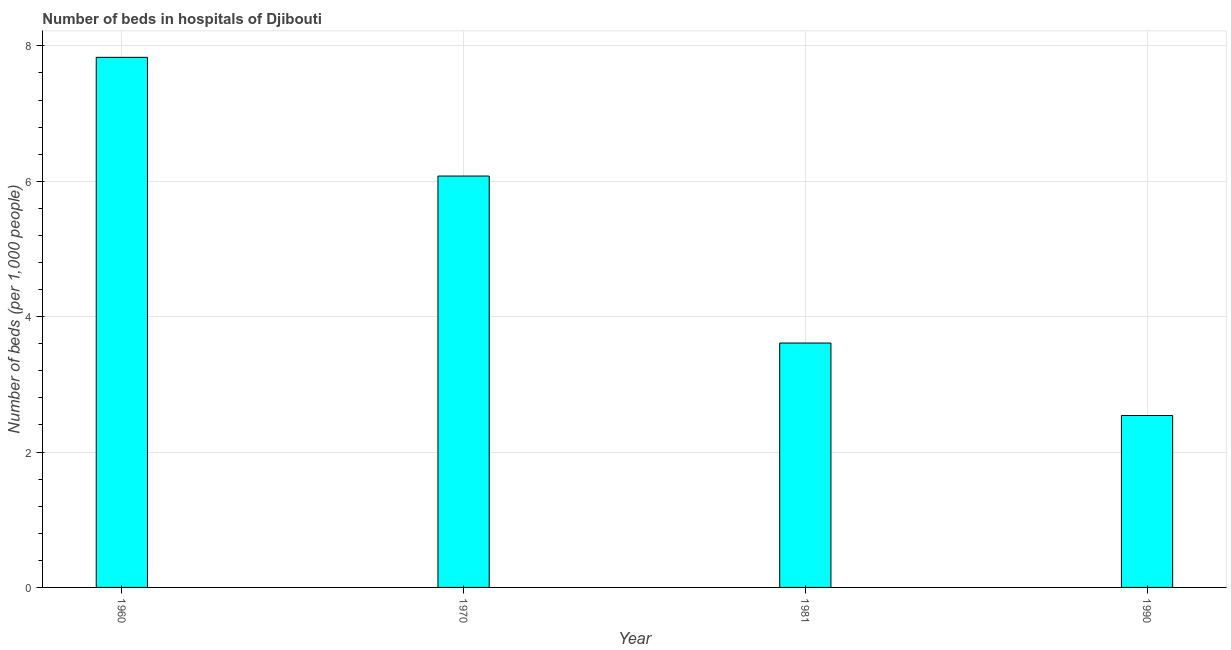Does the graph contain grids?
Make the answer very short. Yes. What is the title of the graph?
Make the answer very short. Number of beds in hospitals of Djibouti. What is the label or title of the Y-axis?
Make the answer very short. Number of beds (per 1,0 people). What is the number of hospital beds in 1960?
Offer a very short reply. 7.83. Across all years, what is the maximum number of hospital beds?
Offer a very short reply. 7.83. Across all years, what is the minimum number of hospital beds?
Ensure brevity in your answer.  2.54. What is the sum of the number of hospital beds?
Provide a short and direct response. 20.06. What is the difference between the number of hospital beds in 1970 and 1990?
Provide a short and direct response. 3.54. What is the average number of hospital beds per year?
Provide a succinct answer. 5.01. What is the median number of hospital beds?
Keep it short and to the point. 4.84. In how many years, is the number of hospital beds greater than 3.6 %?
Your answer should be compact. 3. What is the ratio of the number of hospital beds in 1960 to that in 1990?
Keep it short and to the point. 3.08. Is the number of hospital beds in 1960 less than that in 1970?
Provide a short and direct response. No. Is the difference between the number of hospital beds in 1960 and 1990 greater than the difference between any two years?
Offer a terse response. Yes. What is the difference between the highest and the second highest number of hospital beds?
Give a very brief answer. 1.75. Is the sum of the number of hospital beds in 1960 and 1970 greater than the maximum number of hospital beds across all years?
Your response must be concise. Yes. What is the difference between the highest and the lowest number of hospital beds?
Make the answer very short. 5.29. Are the values on the major ticks of Y-axis written in scientific E-notation?
Keep it short and to the point. No. What is the Number of beds (per 1,000 people) of 1960?
Make the answer very short. 7.83. What is the Number of beds (per 1,000 people) in 1970?
Provide a short and direct response. 6.08. What is the Number of beds (per 1,000 people) in 1981?
Your answer should be compact. 3.61. What is the Number of beds (per 1,000 people) of 1990?
Your response must be concise. 2.54. What is the difference between the Number of beds (per 1,000 people) in 1960 and 1970?
Offer a terse response. 1.75. What is the difference between the Number of beds (per 1,000 people) in 1960 and 1981?
Your response must be concise. 4.22. What is the difference between the Number of beds (per 1,000 people) in 1960 and 1990?
Offer a very short reply. 5.29. What is the difference between the Number of beds (per 1,000 people) in 1970 and 1981?
Provide a short and direct response. 2.47. What is the difference between the Number of beds (per 1,000 people) in 1970 and 1990?
Keep it short and to the point. 3.54. What is the difference between the Number of beds (per 1,000 people) in 1981 and 1990?
Your answer should be compact. 1.07. What is the ratio of the Number of beds (per 1,000 people) in 1960 to that in 1970?
Keep it short and to the point. 1.29. What is the ratio of the Number of beds (per 1,000 people) in 1960 to that in 1981?
Provide a succinct answer. 2.17. What is the ratio of the Number of beds (per 1,000 people) in 1960 to that in 1990?
Give a very brief answer. 3.08. What is the ratio of the Number of beds (per 1,000 people) in 1970 to that in 1981?
Ensure brevity in your answer.  1.68. What is the ratio of the Number of beds (per 1,000 people) in 1970 to that in 1990?
Your answer should be very brief. 2.39. What is the ratio of the Number of beds (per 1,000 people) in 1981 to that in 1990?
Your answer should be compact. 1.42. 